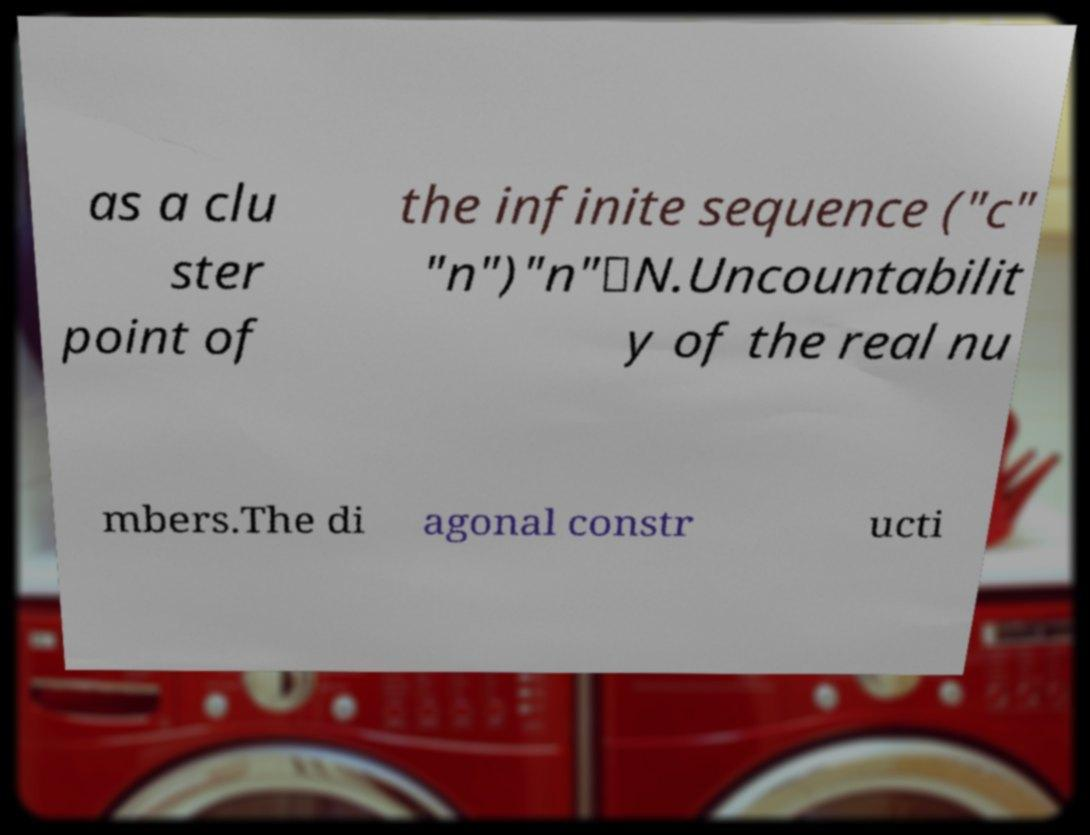There's text embedded in this image that I need extracted. Can you transcribe it verbatim? as a clu ster point of the infinite sequence ("c" "n")"n"∈N.Uncountabilit y of the real nu mbers.The di agonal constr ucti 